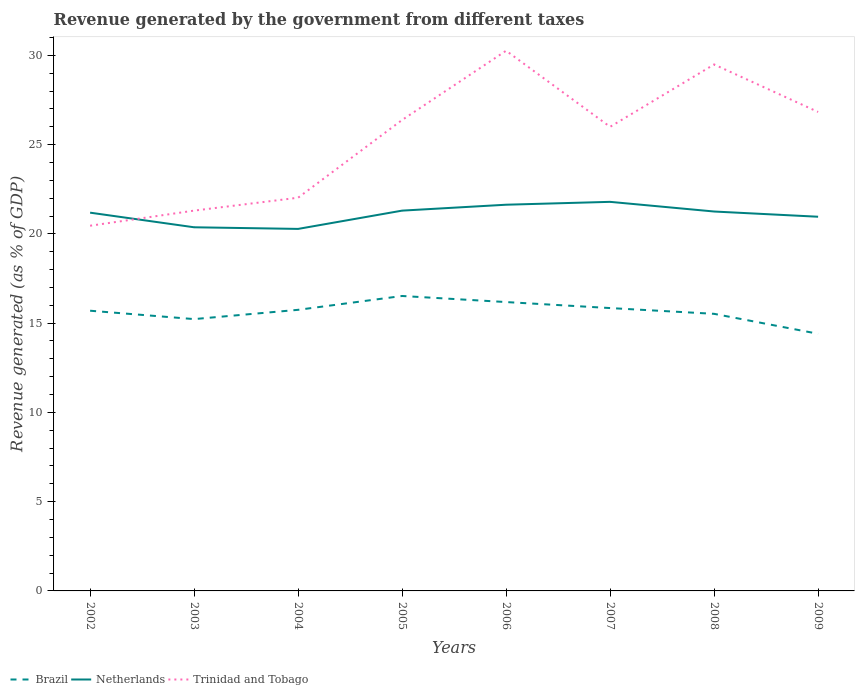Does the line corresponding to Trinidad and Tobago intersect with the line corresponding to Netherlands?
Your response must be concise. Yes. Across all years, what is the maximum revenue generated by the government in Trinidad and Tobago?
Give a very brief answer. 20.46. What is the total revenue generated by the government in Trinidad and Tobago in the graph?
Keep it short and to the point. -7.46. What is the difference between the highest and the second highest revenue generated by the government in Trinidad and Tobago?
Your answer should be compact. 9.8. What is the difference between the highest and the lowest revenue generated by the government in Trinidad and Tobago?
Give a very brief answer. 5. Is the revenue generated by the government in Netherlands strictly greater than the revenue generated by the government in Brazil over the years?
Keep it short and to the point. No. How many lines are there?
Offer a very short reply. 3. Are the values on the major ticks of Y-axis written in scientific E-notation?
Provide a short and direct response. No. Does the graph contain any zero values?
Give a very brief answer. No. Where does the legend appear in the graph?
Make the answer very short. Bottom left. What is the title of the graph?
Provide a succinct answer. Revenue generated by the government from different taxes. What is the label or title of the Y-axis?
Provide a succinct answer. Revenue generated (as % of GDP). What is the Revenue generated (as % of GDP) of Brazil in 2002?
Offer a terse response. 15.69. What is the Revenue generated (as % of GDP) of Netherlands in 2002?
Your answer should be compact. 21.19. What is the Revenue generated (as % of GDP) in Trinidad and Tobago in 2002?
Make the answer very short. 20.46. What is the Revenue generated (as % of GDP) in Brazil in 2003?
Offer a terse response. 15.23. What is the Revenue generated (as % of GDP) in Netherlands in 2003?
Ensure brevity in your answer.  20.37. What is the Revenue generated (as % of GDP) of Trinidad and Tobago in 2003?
Provide a short and direct response. 21.3. What is the Revenue generated (as % of GDP) of Brazil in 2004?
Make the answer very short. 15.75. What is the Revenue generated (as % of GDP) of Netherlands in 2004?
Your answer should be very brief. 20.28. What is the Revenue generated (as % of GDP) in Trinidad and Tobago in 2004?
Your answer should be compact. 22.03. What is the Revenue generated (as % of GDP) of Brazil in 2005?
Give a very brief answer. 16.52. What is the Revenue generated (as % of GDP) in Netherlands in 2005?
Give a very brief answer. 21.3. What is the Revenue generated (as % of GDP) of Trinidad and Tobago in 2005?
Your answer should be compact. 26.38. What is the Revenue generated (as % of GDP) of Brazil in 2006?
Make the answer very short. 16.18. What is the Revenue generated (as % of GDP) of Netherlands in 2006?
Keep it short and to the point. 21.63. What is the Revenue generated (as % of GDP) in Trinidad and Tobago in 2006?
Your answer should be very brief. 30.26. What is the Revenue generated (as % of GDP) in Brazil in 2007?
Your answer should be compact. 15.84. What is the Revenue generated (as % of GDP) in Netherlands in 2007?
Offer a very short reply. 21.79. What is the Revenue generated (as % of GDP) in Trinidad and Tobago in 2007?
Offer a very short reply. 26. What is the Revenue generated (as % of GDP) of Brazil in 2008?
Your answer should be very brief. 15.52. What is the Revenue generated (as % of GDP) of Netherlands in 2008?
Keep it short and to the point. 21.25. What is the Revenue generated (as % of GDP) of Trinidad and Tobago in 2008?
Offer a terse response. 29.49. What is the Revenue generated (as % of GDP) in Brazil in 2009?
Give a very brief answer. 14.4. What is the Revenue generated (as % of GDP) of Netherlands in 2009?
Provide a short and direct response. 20.96. What is the Revenue generated (as % of GDP) in Trinidad and Tobago in 2009?
Offer a terse response. 26.83. Across all years, what is the maximum Revenue generated (as % of GDP) of Brazil?
Your answer should be compact. 16.52. Across all years, what is the maximum Revenue generated (as % of GDP) in Netherlands?
Give a very brief answer. 21.79. Across all years, what is the maximum Revenue generated (as % of GDP) in Trinidad and Tobago?
Your response must be concise. 30.26. Across all years, what is the minimum Revenue generated (as % of GDP) of Brazil?
Provide a short and direct response. 14.4. Across all years, what is the minimum Revenue generated (as % of GDP) in Netherlands?
Offer a terse response. 20.28. Across all years, what is the minimum Revenue generated (as % of GDP) in Trinidad and Tobago?
Ensure brevity in your answer.  20.46. What is the total Revenue generated (as % of GDP) of Brazil in the graph?
Provide a succinct answer. 125.13. What is the total Revenue generated (as % of GDP) in Netherlands in the graph?
Your answer should be very brief. 168.77. What is the total Revenue generated (as % of GDP) of Trinidad and Tobago in the graph?
Offer a very short reply. 202.73. What is the difference between the Revenue generated (as % of GDP) in Brazil in 2002 and that in 2003?
Offer a very short reply. 0.47. What is the difference between the Revenue generated (as % of GDP) in Netherlands in 2002 and that in 2003?
Offer a terse response. 0.82. What is the difference between the Revenue generated (as % of GDP) in Trinidad and Tobago in 2002 and that in 2003?
Keep it short and to the point. -0.85. What is the difference between the Revenue generated (as % of GDP) of Brazil in 2002 and that in 2004?
Offer a very short reply. -0.05. What is the difference between the Revenue generated (as % of GDP) in Netherlands in 2002 and that in 2004?
Ensure brevity in your answer.  0.91. What is the difference between the Revenue generated (as % of GDP) in Trinidad and Tobago in 2002 and that in 2004?
Give a very brief answer. -1.57. What is the difference between the Revenue generated (as % of GDP) in Brazil in 2002 and that in 2005?
Provide a succinct answer. -0.83. What is the difference between the Revenue generated (as % of GDP) in Netherlands in 2002 and that in 2005?
Ensure brevity in your answer.  -0.11. What is the difference between the Revenue generated (as % of GDP) of Trinidad and Tobago in 2002 and that in 2005?
Give a very brief answer. -5.92. What is the difference between the Revenue generated (as % of GDP) of Brazil in 2002 and that in 2006?
Offer a terse response. -0.49. What is the difference between the Revenue generated (as % of GDP) of Netherlands in 2002 and that in 2006?
Make the answer very short. -0.45. What is the difference between the Revenue generated (as % of GDP) in Trinidad and Tobago in 2002 and that in 2006?
Offer a very short reply. -9.8. What is the difference between the Revenue generated (as % of GDP) of Brazil in 2002 and that in 2007?
Give a very brief answer. -0.15. What is the difference between the Revenue generated (as % of GDP) of Netherlands in 2002 and that in 2007?
Your answer should be very brief. -0.61. What is the difference between the Revenue generated (as % of GDP) of Trinidad and Tobago in 2002 and that in 2007?
Make the answer very short. -5.54. What is the difference between the Revenue generated (as % of GDP) of Brazil in 2002 and that in 2008?
Keep it short and to the point. 0.17. What is the difference between the Revenue generated (as % of GDP) in Netherlands in 2002 and that in 2008?
Your answer should be very brief. -0.06. What is the difference between the Revenue generated (as % of GDP) in Trinidad and Tobago in 2002 and that in 2008?
Your answer should be very brief. -9.03. What is the difference between the Revenue generated (as % of GDP) in Brazil in 2002 and that in 2009?
Offer a terse response. 1.29. What is the difference between the Revenue generated (as % of GDP) of Netherlands in 2002 and that in 2009?
Offer a terse response. 0.23. What is the difference between the Revenue generated (as % of GDP) of Trinidad and Tobago in 2002 and that in 2009?
Keep it short and to the point. -6.37. What is the difference between the Revenue generated (as % of GDP) of Brazil in 2003 and that in 2004?
Make the answer very short. -0.52. What is the difference between the Revenue generated (as % of GDP) of Netherlands in 2003 and that in 2004?
Provide a succinct answer. 0.09. What is the difference between the Revenue generated (as % of GDP) in Trinidad and Tobago in 2003 and that in 2004?
Make the answer very short. -0.72. What is the difference between the Revenue generated (as % of GDP) of Brazil in 2003 and that in 2005?
Offer a very short reply. -1.29. What is the difference between the Revenue generated (as % of GDP) in Netherlands in 2003 and that in 2005?
Provide a succinct answer. -0.93. What is the difference between the Revenue generated (as % of GDP) of Trinidad and Tobago in 2003 and that in 2005?
Give a very brief answer. -5.08. What is the difference between the Revenue generated (as % of GDP) in Brazil in 2003 and that in 2006?
Offer a very short reply. -0.95. What is the difference between the Revenue generated (as % of GDP) in Netherlands in 2003 and that in 2006?
Provide a short and direct response. -1.26. What is the difference between the Revenue generated (as % of GDP) in Trinidad and Tobago in 2003 and that in 2006?
Make the answer very short. -8.96. What is the difference between the Revenue generated (as % of GDP) of Brazil in 2003 and that in 2007?
Your answer should be compact. -0.62. What is the difference between the Revenue generated (as % of GDP) in Netherlands in 2003 and that in 2007?
Provide a succinct answer. -1.42. What is the difference between the Revenue generated (as % of GDP) of Trinidad and Tobago in 2003 and that in 2007?
Provide a short and direct response. -4.69. What is the difference between the Revenue generated (as % of GDP) in Brazil in 2003 and that in 2008?
Provide a succinct answer. -0.29. What is the difference between the Revenue generated (as % of GDP) in Netherlands in 2003 and that in 2008?
Offer a very short reply. -0.88. What is the difference between the Revenue generated (as % of GDP) of Trinidad and Tobago in 2003 and that in 2008?
Your answer should be compact. -8.19. What is the difference between the Revenue generated (as % of GDP) in Brazil in 2003 and that in 2009?
Your answer should be compact. 0.82. What is the difference between the Revenue generated (as % of GDP) in Netherlands in 2003 and that in 2009?
Offer a very short reply. -0.59. What is the difference between the Revenue generated (as % of GDP) of Trinidad and Tobago in 2003 and that in 2009?
Your answer should be very brief. -5.53. What is the difference between the Revenue generated (as % of GDP) in Brazil in 2004 and that in 2005?
Keep it short and to the point. -0.78. What is the difference between the Revenue generated (as % of GDP) of Netherlands in 2004 and that in 2005?
Your response must be concise. -1.02. What is the difference between the Revenue generated (as % of GDP) of Trinidad and Tobago in 2004 and that in 2005?
Give a very brief answer. -4.35. What is the difference between the Revenue generated (as % of GDP) of Brazil in 2004 and that in 2006?
Provide a succinct answer. -0.43. What is the difference between the Revenue generated (as % of GDP) of Netherlands in 2004 and that in 2006?
Keep it short and to the point. -1.36. What is the difference between the Revenue generated (as % of GDP) in Trinidad and Tobago in 2004 and that in 2006?
Your answer should be very brief. -8.23. What is the difference between the Revenue generated (as % of GDP) in Brazil in 2004 and that in 2007?
Provide a short and direct response. -0.1. What is the difference between the Revenue generated (as % of GDP) of Netherlands in 2004 and that in 2007?
Provide a short and direct response. -1.52. What is the difference between the Revenue generated (as % of GDP) in Trinidad and Tobago in 2004 and that in 2007?
Provide a short and direct response. -3.97. What is the difference between the Revenue generated (as % of GDP) in Brazil in 2004 and that in 2008?
Offer a terse response. 0.22. What is the difference between the Revenue generated (as % of GDP) of Netherlands in 2004 and that in 2008?
Keep it short and to the point. -0.97. What is the difference between the Revenue generated (as % of GDP) in Trinidad and Tobago in 2004 and that in 2008?
Give a very brief answer. -7.46. What is the difference between the Revenue generated (as % of GDP) of Brazil in 2004 and that in 2009?
Your answer should be compact. 1.34. What is the difference between the Revenue generated (as % of GDP) in Netherlands in 2004 and that in 2009?
Provide a succinct answer. -0.68. What is the difference between the Revenue generated (as % of GDP) in Trinidad and Tobago in 2004 and that in 2009?
Make the answer very short. -4.8. What is the difference between the Revenue generated (as % of GDP) in Brazil in 2005 and that in 2006?
Keep it short and to the point. 0.34. What is the difference between the Revenue generated (as % of GDP) of Netherlands in 2005 and that in 2006?
Your answer should be compact. -0.33. What is the difference between the Revenue generated (as % of GDP) in Trinidad and Tobago in 2005 and that in 2006?
Offer a terse response. -3.88. What is the difference between the Revenue generated (as % of GDP) in Brazil in 2005 and that in 2007?
Your answer should be very brief. 0.68. What is the difference between the Revenue generated (as % of GDP) in Netherlands in 2005 and that in 2007?
Your answer should be very brief. -0.49. What is the difference between the Revenue generated (as % of GDP) in Trinidad and Tobago in 2005 and that in 2007?
Provide a short and direct response. 0.38. What is the difference between the Revenue generated (as % of GDP) of Netherlands in 2005 and that in 2008?
Offer a very short reply. 0.05. What is the difference between the Revenue generated (as % of GDP) of Trinidad and Tobago in 2005 and that in 2008?
Provide a succinct answer. -3.11. What is the difference between the Revenue generated (as % of GDP) in Brazil in 2005 and that in 2009?
Provide a succinct answer. 2.12. What is the difference between the Revenue generated (as % of GDP) of Netherlands in 2005 and that in 2009?
Keep it short and to the point. 0.34. What is the difference between the Revenue generated (as % of GDP) of Trinidad and Tobago in 2005 and that in 2009?
Give a very brief answer. -0.45. What is the difference between the Revenue generated (as % of GDP) in Brazil in 2006 and that in 2007?
Provide a succinct answer. 0.34. What is the difference between the Revenue generated (as % of GDP) of Netherlands in 2006 and that in 2007?
Provide a succinct answer. -0.16. What is the difference between the Revenue generated (as % of GDP) in Trinidad and Tobago in 2006 and that in 2007?
Your response must be concise. 4.26. What is the difference between the Revenue generated (as % of GDP) of Brazil in 2006 and that in 2008?
Your answer should be compact. 0.66. What is the difference between the Revenue generated (as % of GDP) of Netherlands in 2006 and that in 2008?
Give a very brief answer. 0.38. What is the difference between the Revenue generated (as % of GDP) in Trinidad and Tobago in 2006 and that in 2008?
Provide a short and direct response. 0.77. What is the difference between the Revenue generated (as % of GDP) in Brazil in 2006 and that in 2009?
Provide a succinct answer. 1.78. What is the difference between the Revenue generated (as % of GDP) of Netherlands in 2006 and that in 2009?
Provide a short and direct response. 0.67. What is the difference between the Revenue generated (as % of GDP) in Trinidad and Tobago in 2006 and that in 2009?
Provide a succinct answer. 3.43. What is the difference between the Revenue generated (as % of GDP) of Brazil in 2007 and that in 2008?
Keep it short and to the point. 0.32. What is the difference between the Revenue generated (as % of GDP) in Netherlands in 2007 and that in 2008?
Give a very brief answer. 0.54. What is the difference between the Revenue generated (as % of GDP) of Trinidad and Tobago in 2007 and that in 2008?
Offer a terse response. -3.49. What is the difference between the Revenue generated (as % of GDP) of Brazil in 2007 and that in 2009?
Keep it short and to the point. 1.44. What is the difference between the Revenue generated (as % of GDP) in Netherlands in 2007 and that in 2009?
Give a very brief answer. 0.83. What is the difference between the Revenue generated (as % of GDP) in Trinidad and Tobago in 2007 and that in 2009?
Make the answer very short. -0.83. What is the difference between the Revenue generated (as % of GDP) of Brazil in 2008 and that in 2009?
Keep it short and to the point. 1.12. What is the difference between the Revenue generated (as % of GDP) in Netherlands in 2008 and that in 2009?
Offer a very short reply. 0.29. What is the difference between the Revenue generated (as % of GDP) in Trinidad and Tobago in 2008 and that in 2009?
Give a very brief answer. 2.66. What is the difference between the Revenue generated (as % of GDP) in Brazil in 2002 and the Revenue generated (as % of GDP) in Netherlands in 2003?
Offer a very short reply. -4.67. What is the difference between the Revenue generated (as % of GDP) in Brazil in 2002 and the Revenue generated (as % of GDP) in Trinidad and Tobago in 2003?
Provide a succinct answer. -5.61. What is the difference between the Revenue generated (as % of GDP) in Netherlands in 2002 and the Revenue generated (as % of GDP) in Trinidad and Tobago in 2003?
Ensure brevity in your answer.  -0.11. What is the difference between the Revenue generated (as % of GDP) of Brazil in 2002 and the Revenue generated (as % of GDP) of Netherlands in 2004?
Provide a succinct answer. -4.58. What is the difference between the Revenue generated (as % of GDP) in Brazil in 2002 and the Revenue generated (as % of GDP) in Trinidad and Tobago in 2004?
Ensure brevity in your answer.  -6.33. What is the difference between the Revenue generated (as % of GDP) in Netherlands in 2002 and the Revenue generated (as % of GDP) in Trinidad and Tobago in 2004?
Your answer should be compact. -0.84. What is the difference between the Revenue generated (as % of GDP) in Brazil in 2002 and the Revenue generated (as % of GDP) in Netherlands in 2005?
Provide a short and direct response. -5.61. What is the difference between the Revenue generated (as % of GDP) in Brazil in 2002 and the Revenue generated (as % of GDP) in Trinidad and Tobago in 2005?
Make the answer very short. -10.68. What is the difference between the Revenue generated (as % of GDP) of Netherlands in 2002 and the Revenue generated (as % of GDP) of Trinidad and Tobago in 2005?
Provide a short and direct response. -5.19. What is the difference between the Revenue generated (as % of GDP) of Brazil in 2002 and the Revenue generated (as % of GDP) of Netherlands in 2006?
Keep it short and to the point. -5.94. What is the difference between the Revenue generated (as % of GDP) of Brazil in 2002 and the Revenue generated (as % of GDP) of Trinidad and Tobago in 2006?
Ensure brevity in your answer.  -14.56. What is the difference between the Revenue generated (as % of GDP) of Netherlands in 2002 and the Revenue generated (as % of GDP) of Trinidad and Tobago in 2006?
Offer a terse response. -9.07. What is the difference between the Revenue generated (as % of GDP) in Brazil in 2002 and the Revenue generated (as % of GDP) in Netherlands in 2007?
Make the answer very short. -6.1. What is the difference between the Revenue generated (as % of GDP) of Brazil in 2002 and the Revenue generated (as % of GDP) of Trinidad and Tobago in 2007?
Provide a succinct answer. -10.3. What is the difference between the Revenue generated (as % of GDP) of Netherlands in 2002 and the Revenue generated (as % of GDP) of Trinidad and Tobago in 2007?
Offer a very short reply. -4.81. What is the difference between the Revenue generated (as % of GDP) in Brazil in 2002 and the Revenue generated (as % of GDP) in Netherlands in 2008?
Your response must be concise. -5.56. What is the difference between the Revenue generated (as % of GDP) of Brazil in 2002 and the Revenue generated (as % of GDP) of Trinidad and Tobago in 2008?
Ensure brevity in your answer.  -13.79. What is the difference between the Revenue generated (as % of GDP) of Netherlands in 2002 and the Revenue generated (as % of GDP) of Trinidad and Tobago in 2008?
Provide a succinct answer. -8.3. What is the difference between the Revenue generated (as % of GDP) in Brazil in 2002 and the Revenue generated (as % of GDP) in Netherlands in 2009?
Offer a terse response. -5.26. What is the difference between the Revenue generated (as % of GDP) of Brazil in 2002 and the Revenue generated (as % of GDP) of Trinidad and Tobago in 2009?
Your answer should be very brief. -11.13. What is the difference between the Revenue generated (as % of GDP) of Netherlands in 2002 and the Revenue generated (as % of GDP) of Trinidad and Tobago in 2009?
Provide a succinct answer. -5.64. What is the difference between the Revenue generated (as % of GDP) in Brazil in 2003 and the Revenue generated (as % of GDP) in Netherlands in 2004?
Your answer should be compact. -5.05. What is the difference between the Revenue generated (as % of GDP) in Brazil in 2003 and the Revenue generated (as % of GDP) in Trinidad and Tobago in 2004?
Give a very brief answer. -6.8. What is the difference between the Revenue generated (as % of GDP) of Netherlands in 2003 and the Revenue generated (as % of GDP) of Trinidad and Tobago in 2004?
Offer a very short reply. -1.66. What is the difference between the Revenue generated (as % of GDP) in Brazil in 2003 and the Revenue generated (as % of GDP) in Netherlands in 2005?
Your answer should be compact. -6.08. What is the difference between the Revenue generated (as % of GDP) of Brazil in 2003 and the Revenue generated (as % of GDP) of Trinidad and Tobago in 2005?
Your answer should be very brief. -11.15. What is the difference between the Revenue generated (as % of GDP) in Netherlands in 2003 and the Revenue generated (as % of GDP) in Trinidad and Tobago in 2005?
Offer a very short reply. -6.01. What is the difference between the Revenue generated (as % of GDP) in Brazil in 2003 and the Revenue generated (as % of GDP) in Netherlands in 2006?
Your answer should be very brief. -6.41. What is the difference between the Revenue generated (as % of GDP) of Brazil in 2003 and the Revenue generated (as % of GDP) of Trinidad and Tobago in 2006?
Offer a terse response. -15.03. What is the difference between the Revenue generated (as % of GDP) of Netherlands in 2003 and the Revenue generated (as % of GDP) of Trinidad and Tobago in 2006?
Your response must be concise. -9.89. What is the difference between the Revenue generated (as % of GDP) of Brazil in 2003 and the Revenue generated (as % of GDP) of Netherlands in 2007?
Keep it short and to the point. -6.57. What is the difference between the Revenue generated (as % of GDP) of Brazil in 2003 and the Revenue generated (as % of GDP) of Trinidad and Tobago in 2007?
Give a very brief answer. -10.77. What is the difference between the Revenue generated (as % of GDP) of Netherlands in 2003 and the Revenue generated (as % of GDP) of Trinidad and Tobago in 2007?
Your answer should be compact. -5.63. What is the difference between the Revenue generated (as % of GDP) of Brazil in 2003 and the Revenue generated (as % of GDP) of Netherlands in 2008?
Provide a short and direct response. -6.03. What is the difference between the Revenue generated (as % of GDP) of Brazil in 2003 and the Revenue generated (as % of GDP) of Trinidad and Tobago in 2008?
Your answer should be compact. -14.26. What is the difference between the Revenue generated (as % of GDP) of Netherlands in 2003 and the Revenue generated (as % of GDP) of Trinidad and Tobago in 2008?
Your answer should be very brief. -9.12. What is the difference between the Revenue generated (as % of GDP) of Brazil in 2003 and the Revenue generated (as % of GDP) of Netherlands in 2009?
Ensure brevity in your answer.  -5.73. What is the difference between the Revenue generated (as % of GDP) in Brazil in 2003 and the Revenue generated (as % of GDP) in Trinidad and Tobago in 2009?
Provide a short and direct response. -11.6. What is the difference between the Revenue generated (as % of GDP) in Netherlands in 2003 and the Revenue generated (as % of GDP) in Trinidad and Tobago in 2009?
Your answer should be very brief. -6.46. What is the difference between the Revenue generated (as % of GDP) in Brazil in 2004 and the Revenue generated (as % of GDP) in Netherlands in 2005?
Provide a succinct answer. -5.56. What is the difference between the Revenue generated (as % of GDP) of Brazil in 2004 and the Revenue generated (as % of GDP) of Trinidad and Tobago in 2005?
Your answer should be compact. -10.63. What is the difference between the Revenue generated (as % of GDP) of Netherlands in 2004 and the Revenue generated (as % of GDP) of Trinidad and Tobago in 2005?
Your response must be concise. -6.1. What is the difference between the Revenue generated (as % of GDP) in Brazil in 2004 and the Revenue generated (as % of GDP) in Netherlands in 2006?
Make the answer very short. -5.89. What is the difference between the Revenue generated (as % of GDP) of Brazil in 2004 and the Revenue generated (as % of GDP) of Trinidad and Tobago in 2006?
Offer a terse response. -14.51. What is the difference between the Revenue generated (as % of GDP) in Netherlands in 2004 and the Revenue generated (as % of GDP) in Trinidad and Tobago in 2006?
Keep it short and to the point. -9.98. What is the difference between the Revenue generated (as % of GDP) in Brazil in 2004 and the Revenue generated (as % of GDP) in Netherlands in 2007?
Your response must be concise. -6.05. What is the difference between the Revenue generated (as % of GDP) in Brazil in 2004 and the Revenue generated (as % of GDP) in Trinidad and Tobago in 2007?
Provide a succinct answer. -10.25. What is the difference between the Revenue generated (as % of GDP) of Netherlands in 2004 and the Revenue generated (as % of GDP) of Trinidad and Tobago in 2007?
Provide a succinct answer. -5.72. What is the difference between the Revenue generated (as % of GDP) of Brazil in 2004 and the Revenue generated (as % of GDP) of Netherlands in 2008?
Make the answer very short. -5.51. What is the difference between the Revenue generated (as % of GDP) of Brazil in 2004 and the Revenue generated (as % of GDP) of Trinidad and Tobago in 2008?
Your answer should be compact. -13.74. What is the difference between the Revenue generated (as % of GDP) in Netherlands in 2004 and the Revenue generated (as % of GDP) in Trinidad and Tobago in 2008?
Offer a very short reply. -9.21. What is the difference between the Revenue generated (as % of GDP) in Brazil in 2004 and the Revenue generated (as % of GDP) in Netherlands in 2009?
Offer a terse response. -5.21. What is the difference between the Revenue generated (as % of GDP) in Brazil in 2004 and the Revenue generated (as % of GDP) in Trinidad and Tobago in 2009?
Offer a terse response. -11.08. What is the difference between the Revenue generated (as % of GDP) of Netherlands in 2004 and the Revenue generated (as % of GDP) of Trinidad and Tobago in 2009?
Your response must be concise. -6.55. What is the difference between the Revenue generated (as % of GDP) in Brazil in 2005 and the Revenue generated (as % of GDP) in Netherlands in 2006?
Keep it short and to the point. -5.11. What is the difference between the Revenue generated (as % of GDP) in Brazil in 2005 and the Revenue generated (as % of GDP) in Trinidad and Tobago in 2006?
Your answer should be very brief. -13.74. What is the difference between the Revenue generated (as % of GDP) in Netherlands in 2005 and the Revenue generated (as % of GDP) in Trinidad and Tobago in 2006?
Your answer should be compact. -8.96. What is the difference between the Revenue generated (as % of GDP) in Brazil in 2005 and the Revenue generated (as % of GDP) in Netherlands in 2007?
Offer a very short reply. -5.27. What is the difference between the Revenue generated (as % of GDP) in Brazil in 2005 and the Revenue generated (as % of GDP) in Trinidad and Tobago in 2007?
Keep it short and to the point. -9.47. What is the difference between the Revenue generated (as % of GDP) in Netherlands in 2005 and the Revenue generated (as % of GDP) in Trinidad and Tobago in 2007?
Keep it short and to the point. -4.69. What is the difference between the Revenue generated (as % of GDP) in Brazil in 2005 and the Revenue generated (as % of GDP) in Netherlands in 2008?
Offer a terse response. -4.73. What is the difference between the Revenue generated (as % of GDP) in Brazil in 2005 and the Revenue generated (as % of GDP) in Trinidad and Tobago in 2008?
Your answer should be very brief. -12.97. What is the difference between the Revenue generated (as % of GDP) in Netherlands in 2005 and the Revenue generated (as % of GDP) in Trinidad and Tobago in 2008?
Provide a short and direct response. -8.19. What is the difference between the Revenue generated (as % of GDP) in Brazil in 2005 and the Revenue generated (as % of GDP) in Netherlands in 2009?
Ensure brevity in your answer.  -4.44. What is the difference between the Revenue generated (as % of GDP) in Brazil in 2005 and the Revenue generated (as % of GDP) in Trinidad and Tobago in 2009?
Provide a succinct answer. -10.31. What is the difference between the Revenue generated (as % of GDP) of Netherlands in 2005 and the Revenue generated (as % of GDP) of Trinidad and Tobago in 2009?
Your answer should be compact. -5.53. What is the difference between the Revenue generated (as % of GDP) of Brazil in 2006 and the Revenue generated (as % of GDP) of Netherlands in 2007?
Your answer should be very brief. -5.61. What is the difference between the Revenue generated (as % of GDP) of Brazil in 2006 and the Revenue generated (as % of GDP) of Trinidad and Tobago in 2007?
Make the answer very short. -9.82. What is the difference between the Revenue generated (as % of GDP) of Netherlands in 2006 and the Revenue generated (as % of GDP) of Trinidad and Tobago in 2007?
Offer a very short reply. -4.36. What is the difference between the Revenue generated (as % of GDP) in Brazil in 2006 and the Revenue generated (as % of GDP) in Netherlands in 2008?
Give a very brief answer. -5.07. What is the difference between the Revenue generated (as % of GDP) in Brazil in 2006 and the Revenue generated (as % of GDP) in Trinidad and Tobago in 2008?
Your answer should be compact. -13.31. What is the difference between the Revenue generated (as % of GDP) of Netherlands in 2006 and the Revenue generated (as % of GDP) of Trinidad and Tobago in 2008?
Offer a terse response. -7.86. What is the difference between the Revenue generated (as % of GDP) of Brazil in 2006 and the Revenue generated (as % of GDP) of Netherlands in 2009?
Make the answer very short. -4.78. What is the difference between the Revenue generated (as % of GDP) in Brazil in 2006 and the Revenue generated (as % of GDP) in Trinidad and Tobago in 2009?
Your response must be concise. -10.65. What is the difference between the Revenue generated (as % of GDP) of Netherlands in 2006 and the Revenue generated (as % of GDP) of Trinidad and Tobago in 2009?
Your answer should be very brief. -5.2. What is the difference between the Revenue generated (as % of GDP) of Brazil in 2007 and the Revenue generated (as % of GDP) of Netherlands in 2008?
Offer a very short reply. -5.41. What is the difference between the Revenue generated (as % of GDP) in Brazil in 2007 and the Revenue generated (as % of GDP) in Trinidad and Tobago in 2008?
Provide a succinct answer. -13.64. What is the difference between the Revenue generated (as % of GDP) in Netherlands in 2007 and the Revenue generated (as % of GDP) in Trinidad and Tobago in 2008?
Provide a succinct answer. -7.7. What is the difference between the Revenue generated (as % of GDP) in Brazil in 2007 and the Revenue generated (as % of GDP) in Netherlands in 2009?
Your answer should be compact. -5.12. What is the difference between the Revenue generated (as % of GDP) in Brazil in 2007 and the Revenue generated (as % of GDP) in Trinidad and Tobago in 2009?
Offer a very short reply. -10.98. What is the difference between the Revenue generated (as % of GDP) of Netherlands in 2007 and the Revenue generated (as % of GDP) of Trinidad and Tobago in 2009?
Provide a short and direct response. -5.03. What is the difference between the Revenue generated (as % of GDP) in Brazil in 2008 and the Revenue generated (as % of GDP) in Netherlands in 2009?
Keep it short and to the point. -5.44. What is the difference between the Revenue generated (as % of GDP) of Brazil in 2008 and the Revenue generated (as % of GDP) of Trinidad and Tobago in 2009?
Make the answer very short. -11.31. What is the difference between the Revenue generated (as % of GDP) in Netherlands in 2008 and the Revenue generated (as % of GDP) in Trinidad and Tobago in 2009?
Provide a short and direct response. -5.58. What is the average Revenue generated (as % of GDP) of Brazil per year?
Your answer should be compact. 15.64. What is the average Revenue generated (as % of GDP) of Netherlands per year?
Provide a succinct answer. 21.1. What is the average Revenue generated (as % of GDP) in Trinidad and Tobago per year?
Your response must be concise. 25.34. In the year 2002, what is the difference between the Revenue generated (as % of GDP) in Brazil and Revenue generated (as % of GDP) in Netherlands?
Provide a succinct answer. -5.49. In the year 2002, what is the difference between the Revenue generated (as % of GDP) in Brazil and Revenue generated (as % of GDP) in Trinidad and Tobago?
Provide a succinct answer. -4.76. In the year 2002, what is the difference between the Revenue generated (as % of GDP) in Netherlands and Revenue generated (as % of GDP) in Trinidad and Tobago?
Your answer should be compact. 0.73. In the year 2003, what is the difference between the Revenue generated (as % of GDP) in Brazil and Revenue generated (as % of GDP) in Netherlands?
Ensure brevity in your answer.  -5.14. In the year 2003, what is the difference between the Revenue generated (as % of GDP) in Brazil and Revenue generated (as % of GDP) in Trinidad and Tobago?
Keep it short and to the point. -6.08. In the year 2003, what is the difference between the Revenue generated (as % of GDP) in Netherlands and Revenue generated (as % of GDP) in Trinidad and Tobago?
Offer a terse response. -0.93. In the year 2004, what is the difference between the Revenue generated (as % of GDP) in Brazil and Revenue generated (as % of GDP) in Netherlands?
Offer a terse response. -4.53. In the year 2004, what is the difference between the Revenue generated (as % of GDP) in Brazil and Revenue generated (as % of GDP) in Trinidad and Tobago?
Offer a terse response. -6.28. In the year 2004, what is the difference between the Revenue generated (as % of GDP) of Netherlands and Revenue generated (as % of GDP) of Trinidad and Tobago?
Keep it short and to the point. -1.75. In the year 2005, what is the difference between the Revenue generated (as % of GDP) of Brazil and Revenue generated (as % of GDP) of Netherlands?
Your response must be concise. -4.78. In the year 2005, what is the difference between the Revenue generated (as % of GDP) in Brazil and Revenue generated (as % of GDP) in Trinidad and Tobago?
Your answer should be very brief. -9.86. In the year 2005, what is the difference between the Revenue generated (as % of GDP) in Netherlands and Revenue generated (as % of GDP) in Trinidad and Tobago?
Keep it short and to the point. -5.08. In the year 2006, what is the difference between the Revenue generated (as % of GDP) of Brazil and Revenue generated (as % of GDP) of Netherlands?
Your answer should be very brief. -5.45. In the year 2006, what is the difference between the Revenue generated (as % of GDP) of Brazil and Revenue generated (as % of GDP) of Trinidad and Tobago?
Your answer should be very brief. -14.08. In the year 2006, what is the difference between the Revenue generated (as % of GDP) of Netherlands and Revenue generated (as % of GDP) of Trinidad and Tobago?
Make the answer very short. -8.63. In the year 2007, what is the difference between the Revenue generated (as % of GDP) in Brazil and Revenue generated (as % of GDP) in Netherlands?
Offer a terse response. -5.95. In the year 2007, what is the difference between the Revenue generated (as % of GDP) of Brazil and Revenue generated (as % of GDP) of Trinidad and Tobago?
Ensure brevity in your answer.  -10.15. In the year 2007, what is the difference between the Revenue generated (as % of GDP) in Netherlands and Revenue generated (as % of GDP) in Trinidad and Tobago?
Your response must be concise. -4.2. In the year 2008, what is the difference between the Revenue generated (as % of GDP) in Brazil and Revenue generated (as % of GDP) in Netherlands?
Make the answer very short. -5.73. In the year 2008, what is the difference between the Revenue generated (as % of GDP) in Brazil and Revenue generated (as % of GDP) in Trinidad and Tobago?
Make the answer very short. -13.97. In the year 2008, what is the difference between the Revenue generated (as % of GDP) in Netherlands and Revenue generated (as % of GDP) in Trinidad and Tobago?
Your response must be concise. -8.24. In the year 2009, what is the difference between the Revenue generated (as % of GDP) in Brazil and Revenue generated (as % of GDP) in Netherlands?
Offer a terse response. -6.55. In the year 2009, what is the difference between the Revenue generated (as % of GDP) of Brazil and Revenue generated (as % of GDP) of Trinidad and Tobago?
Give a very brief answer. -12.42. In the year 2009, what is the difference between the Revenue generated (as % of GDP) of Netherlands and Revenue generated (as % of GDP) of Trinidad and Tobago?
Provide a succinct answer. -5.87. What is the ratio of the Revenue generated (as % of GDP) in Brazil in 2002 to that in 2003?
Keep it short and to the point. 1.03. What is the ratio of the Revenue generated (as % of GDP) of Netherlands in 2002 to that in 2003?
Offer a very short reply. 1.04. What is the ratio of the Revenue generated (as % of GDP) in Trinidad and Tobago in 2002 to that in 2003?
Provide a succinct answer. 0.96. What is the ratio of the Revenue generated (as % of GDP) in Netherlands in 2002 to that in 2004?
Give a very brief answer. 1.04. What is the ratio of the Revenue generated (as % of GDP) in Trinidad and Tobago in 2002 to that in 2004?
Offer a terse response. 0.93. What is the ratio of the Revenue generated (as % of GDP) of Brazil in 2002 to that in 2005?
Your answer should be very brief. 0.95. What is the ratio of the Revenue generated (as % of GDP) of Netherlands in 2002 to that in 2005?
Provide a succinct answer. 0.99. What is the ratio of the Revenue generated (as % of GDP) in Trinidad and Tobago in 2002 to that in 2005?
Provide a succinct answer. 0.78. What is the ratio of the Revenue generated (as % of GDP) in Brazil in 2002 to that in 2006?
Your response must be concise. 0.97. What is the ratio of the Revenue generated (as % of GDP) of Netherlands in 2002 to that in 2006?
Your answer should be compact. 0.98. What is the ratio of the Revenue generated (as % of GDP) of Trinidad and Tobago in 2002 to that in 2006?
Ensure brevity in your answer.  0.68. What is the ratio of the Revenue generated (as % of GDP) of Brazil in 2002 to that in 2007?
Ensure brevity in your answer.  0.99. What is the ratio of the Revenue generated (as % of GDP) of Netherlands in 2002 to that in 2007?
Your response must be concise. 0.97. What is the ratio of the Revenue generated (as % of GDP) in Trinidad and Tobago in 2002 to that in 2007?
Offer a terse response. 0.79. What is the ratio of the Revenue generated (as % of GDP) of Brazil in 2002 to that in 2008?
Provide a short and direct response. 1.01. What is the ratio of the Revenue generated (as % of GDP) of Netherlands in 2002 to that in 2008?
Provide a succinct answer. 1. What is the ratio of the Revenue generated (as % of GDP) of Trinidad and Tobago in 2002 to that in 2008?
Offer a terse response. 0.69. What is the ratio of the Revenue generated (as % of GDP) of Brazil in 2002 to that in 2009?
Your answer should be very brief. 1.09. What is the ratio of the Revenue generated (as % of GDP) in Netherlands in 2002 to that in 2009?
Your answer should be very brief. 1.01. What is the ratio of the Revenue generated (as % of GDP) in Trinidad and Tobago in 2002 to that in 2009?
Provide a succinct answer. 0.76. What is the ratio of the Revenue generated (as % of GDP) of Netherlands in 2003 to that in 2004?
Offer a terse response. 1. What is the ratio of the Revenue generated (as % of GDP) of Trinidad and Tobago in 2003 to that in 2004?
Provide a short and direct response. 0.97. What is the ratio of the Revenue generated (as % of GDP) of Brazil in 2003 to that in 2005?
Make the answer very short. 0.92. What is the ratio of the Revenue generated (as % of GDP) of Netherlands in 2003 to that in 2005?
Provide a short and direct response. 0.96. What is the ratio of the Revenue generated (as % of GDP) in Trinidad and Tobago in 2003 to that in 2005?
Your response must be concise. 0.81. What is the ratio of the Revenue generated (as % of GDP) of Brazil in 2003 to that in 2006?
Your answer should be compact. 0.94. What is the ratio of the Revenue generated (as % of GDP) of Netherlands in 2003 to that in 2006?
Give a very brief answer. 0.94. What is the ratio of the Revenue generated (as % of GDP) in Trinidad and Tobago in 2003 to that in 2006?
Offer a terse response. 0.7. What is the ratio of the Revenue generated (as % of GDP) in Netherlands in 2003 to that in 2007?
Your answer should be very brief. 0.93. What is the ratio of the Revenue generated (as % of GDP) in Trinidad and Tobago in 2003 to that in 2007?
Give a very brief answer. 0.82. What is the ratio of the Revenue generated (as % of GDP) in Netherlands in 2003 to that in 2008?
Your answer should be very brief. 0.96. What is the ratio of the Revenue generated (as % of GDP) of Trinidad and Tobago in 2003 to that in 2008?
Offer a very short reply. 0.72. What is the ratio of the Revenue generated (as % of GDP) of Brazil in 2003 to that in 2009?
Provide a succinct answer. 1.06. What is the ratio of the Revenue generated (as % of GDP) of Netherlands in 2003 to that in 2009?
Offer a terse response. 0.97. What is the ratio of the Revenue generated (as % of GDP) of Trinidad and Tobago in 2003 to that in 2009?
Offer a terse response. 0.79. What is the ratio of the Revenue generated (as % of GDP) in Brazil in 2004 to that in 2005?
Offer a terse response. 0.95. What is the ratio of the Revenue generated (as % of GDP) in Netherlands in 2004 to that in 2005?
Provide a succinct answer. 0.95. What is the ratio of the Revenue generated (as % of GDP) of Trinidad and Tobago in 2004 to that in 2005?
Your answer should be compact. 0.83. What is the ratio of the Revenue generated (as % of GDP) of Brazil in 2004 to that in 2006?
Provide a short and direct response. 0.97. What is the ratio of the Revenue generated (as % of GDP) of Netherlands in 2004 to that in 2006?
Offer a very short reply. 0.94. What is the ratio of the Revenue generated (as % of GDP) of Trinidad and Tobago in 2004 to that in 2006?
Your answer should be compact. 0.73. What is the ratio of the Revenue generated (as % of GDP) of Netherlands in 2004 to that in 2007?
Offer a very short reply. 0.93. What is the ratio of the Revenue generated (as % of GDP) in Trinidad and Tobago in 2004 to that in 2007?
Provide a succinct answer. 0.85. What is the ratio of the Revenue generated (as % of GDP) in Brazil in 2004 to that in 2008?
Make the answer very short. 1.01. What is the ratio of the Revenue generated (as % of GDP) in Netherlands in 2004 to that in 2008?
Ensure brevity in your answer.  0.95. What is the ratio of the Revenue generated (as % of GDP) of Trinidad and Tobago in 2004 to that in 2008?
Provide a short and direct response. 0.75. What is the ratio of the Revenue generated (as % of GDP) of Brazil in 2004 to that in 2009?
Provide a succinct answer. 1.09. What is the ratio of the Revenue generated (as % of GDP) of Netherlands in 2004 to that in 2009?
Make the answer very short. 0.97. What is the ratio of the Revenue generated (as % of GDP) in Trinidad and Tobago in 2004 to that in 2009?
Your response must be concise. 0.82. What is the ratio of the Revenue generated (as % of GDP) in Netherlands in 2005 to that in 2006?
Your response must be concise. 0.98. What is the ratio of the Revenue generated (as % of GDP) of Trinidad and Tobago in 2005 to that in 2006?
Make the answer very short. 0.87. What is the ratio of the Revenue generated (as % of GDP) in Brazil in 2005 to that in 2007?
Provide a succinct answer. 1.04. What is the ratio of the Revenue generated (as % of GDP) of Netherlands in 2005 to that in 2007?
Your response must be concise. 0.98. What is the ratio of the Revenue generated (as % of GDP) of Trinidad and Tobago in 2005 to that in 2007?
Make the answer very short. 1.01. What is the ratio of the Revenue generated (as % of GDP) in Brazil in 2005 to that in 2008?
Make the answer very short. 1.06. What is the ratio of the Revenue generated (as % of GDP) of Trinidad and Tobago in 2005 to that in 2008?
Provide a succinct answer. 0.89. What is the ratio of the Revenue generated (as % of GDP) of Brazil in 2005 to that in 2009?
Make the answer very short. 1.15. What is the ratio of the Revenue generated (as % of GDP) of Netherlands in 2005 to that in 2009?
Keep it short and to the point. 1.02. What is the ratio of the Revenue generated (as % of GDP) of Trinidad and Tobago in 2005 to that in 2009?
Keep it short and to the point. 0.98. What is the ratio of the Revenue generated (as % of GDP) of Brazil in 2006 to that in 2007?
Your answer should be compact. 1.02. What is the ratio of the Revenue generated (as % of GDP) in Trinidad and Tobago in 2006 to that in 2007?
Offer a very short reply. 1.16. What is the ratio of the Revenue generated (as % of GDP) of Brazil in 2006 to that in 2008?
Provide a succinct answer. 1.04. What is the ratio of the Revenue generated (as % of GDP) of Netherlands in 2006 to that in 2008?
Keep it short and to the point. 1.02. What is the ratio of the Revenue generated (as % of GDP) in Trinidad and Tobago in 2006 to that in 2008?
Offer a very short reply. 1.03. What is the ratio of the Revenue generated (as % of GDP) in Brazil in 2006 to that in 2009?
Give a very brief answer. 1.12. What is the ratio of the Revenue generated (as % of GDP) in Netherlands in 2006 to that in 2009?
Your response must be concise. 1.03. What is the ratio of the Revenue generated (as % of GDP) in Trinidad and Tobago in 2006 to that in 2009?
Offer a terse response. 1.13. What is the ratio of the Revenue generated (as % of GDP) of Brazil in 2007 to that in 2008?
Give a very brief answer. 1.02. What is the ratio of the Revenue generated (as % of GDP) of Netherlands in 2007 to that in 2008?
Give a very brief answer. 1.03. What is the ratio of the Revenue generated (as % of GDP) of Trinidad and Tobago in 2007 to that in 2008?
Your answer should be compact. 0.88. What is the ratio of the Revenue generated (as % of GDP) of Brazil in 2007 to that in 2009?
Offer a terse response. 1.1. What is the ratio of the Revenue generated (as % of GDP) of Netherlands in 2007 to that in 2009?
Give a very brief answer. 1.04. What is the ratio of the Revenue generated (as % of GDP) in Brazil in 2008 to that in 2009?
Provide a short and direct response. 1.08. What is the ratio of the Revenue generated (as % of GDP) in Trinidad and Tobago in 2008 to that in 2009?
Ensure brevity in your answer.  1.1. What is the difference between the highest and the second highest Revenue generated (as % of GDP) in Brazil?
Your answer should be very brief. 0.34. What is the difference between the highest and the second highest Revenue generated (as % of GDP) in Netherlands?
Offer a very short reply. 0.16. What is the difference between the highest and the second highest Revenue generated (as % of GDP) of Trinidad and Tobago?
Your answer should be very brief. 0.77. What is the difference between the highest and the lowest Revenue generated (as % of GDP) of Brazil?
Provide a succinct answer. 2.12. What is the difference between the highest and the lowest Revenue generated (as % of GDP) in Netherlands?
Offer a very short reply. 1.52. What is the difference between the highest and the lowest Revenue generated (as % of GDP) of Trinidad and Tobago?
Ensure brevity in your answer.  9.8. 